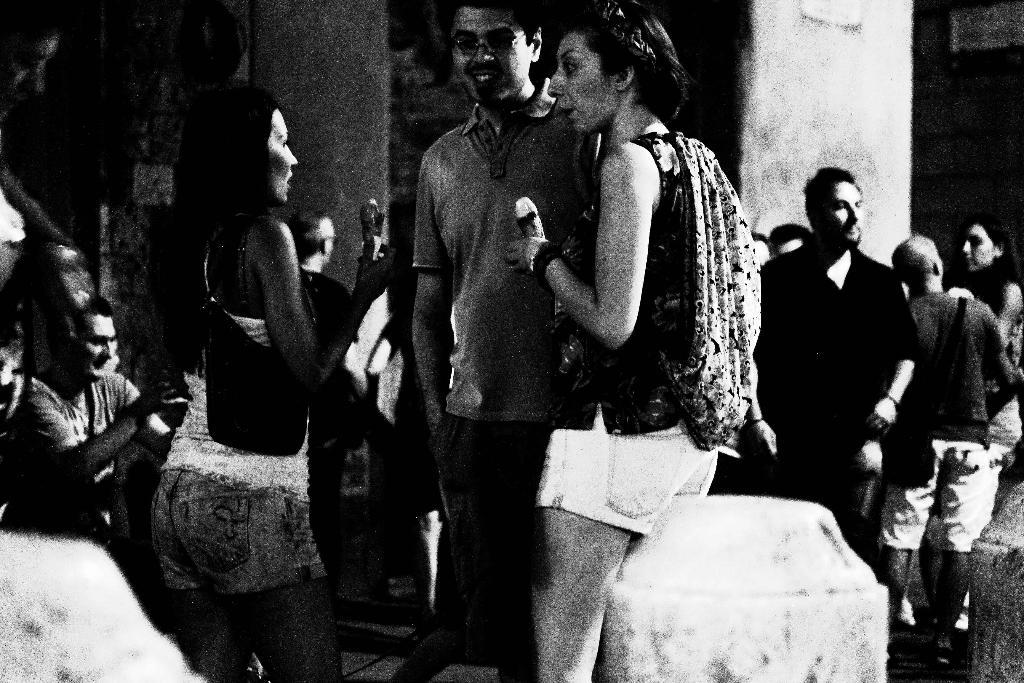What can be seen on the right side of the image? There are people on the right side of the image. What can be seen on the left side of the image? There are people on the left side of the image. What type of scene is depicted in the image? The image appears to be a roadside view. What type of books are the people reading in the image? There are no books present in the image; it depicts people on both sides of a roadside view. 